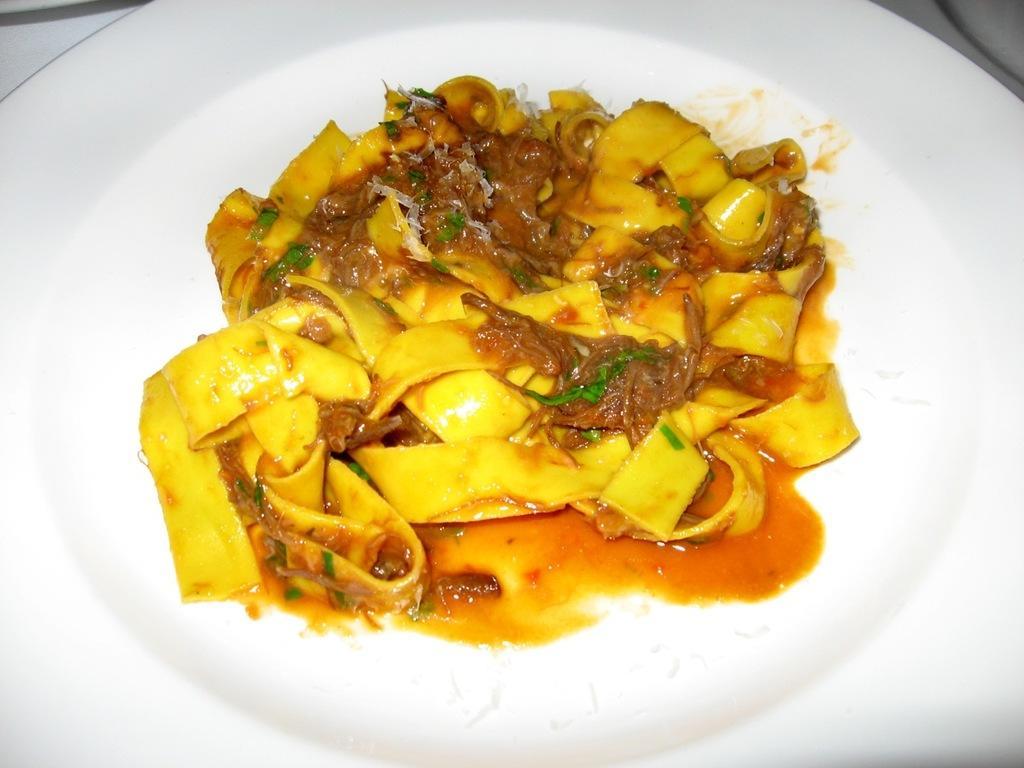Could you give a brief overview of what you see in this image? There is a food item kept in a white color plate as we can see in the middle of this image. 